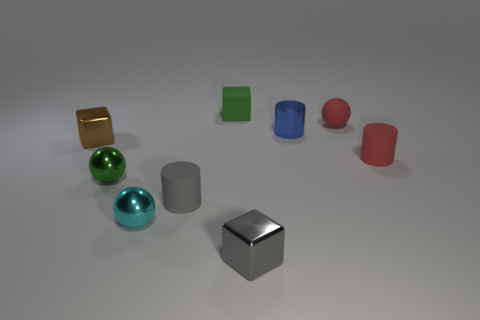What is the size of the green thing that is made of the same material as the tiny blue object?
Offer a very short reply. Small. Are there any other things that are the same color as the small rubber block?
Make the answer very short. Yes. Do the small green sphere and the small cylinder behind the small brown metal cube have the same material?
Give a very brief answer. Yes. There is a small red object that is the same shape as the cyan shiny object; what is its material?
Offer a very short reply. Rubber. Is the material of the green object that is left of the tiny gray cylinder the same as the tiny cylinder that is left of the green matte block?
Provide a short and direct response. No. The small sphere that is behind the small metallic block behind the tiny metal block to the right of the green block is what color?
Offer a terse response. Red. What number of other things are there of the same shape as the green shiny thing?
Provide a short and direct response. 2. What number of objects are either tiny gray cylinders or rubber things right of the gray rubber cylinder?
Provide a short and direct response. 4. Are there any rubber cubes of the same size as the cyan metallic sphere?
Ensure brevity in your answer.  Yes. Does the tiny red cylinder have the same material as the tiny red ball?
Provide a succinct answer. Yes. 